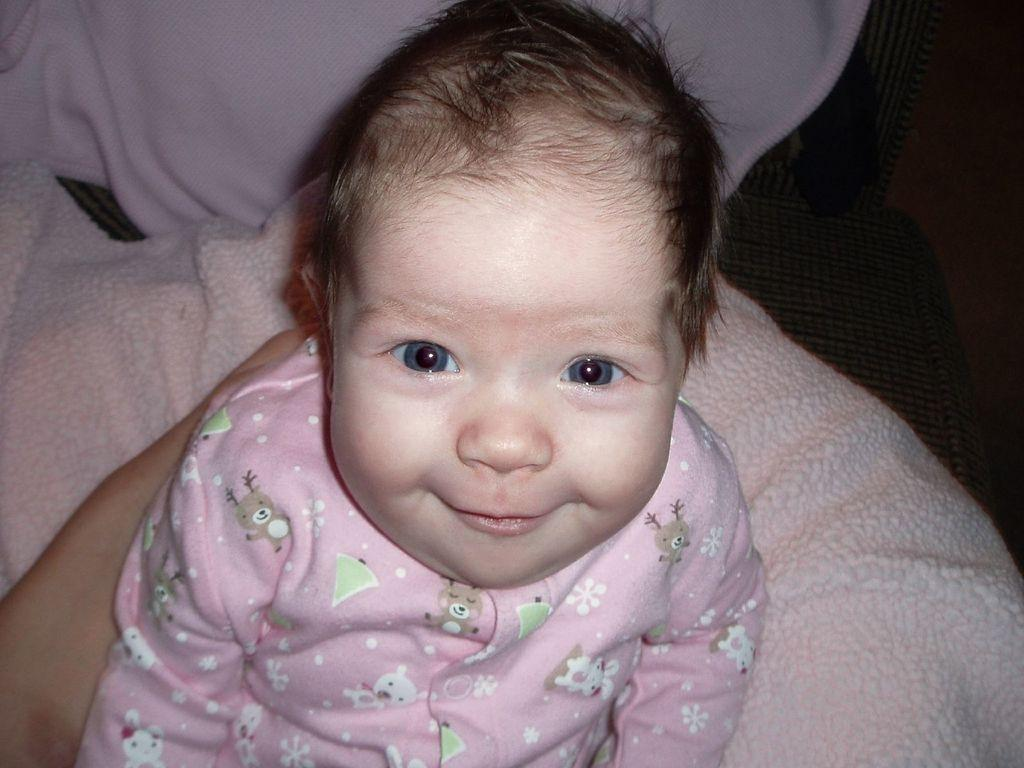What is the main subject in the center of the image? There is a kid in the center of the image. What is the kid's expression in the image? The kid is smiling. What type of object is at the bottom of the image? There is a cloth at the bottom of the image. Whose hand is visible on the left side of the image? A person's hand is visible on the left side of the image. How many horses are present in the image? There are no horses visible in the image. In which direction is the vase facing in the image? There is no vase present in the image. 